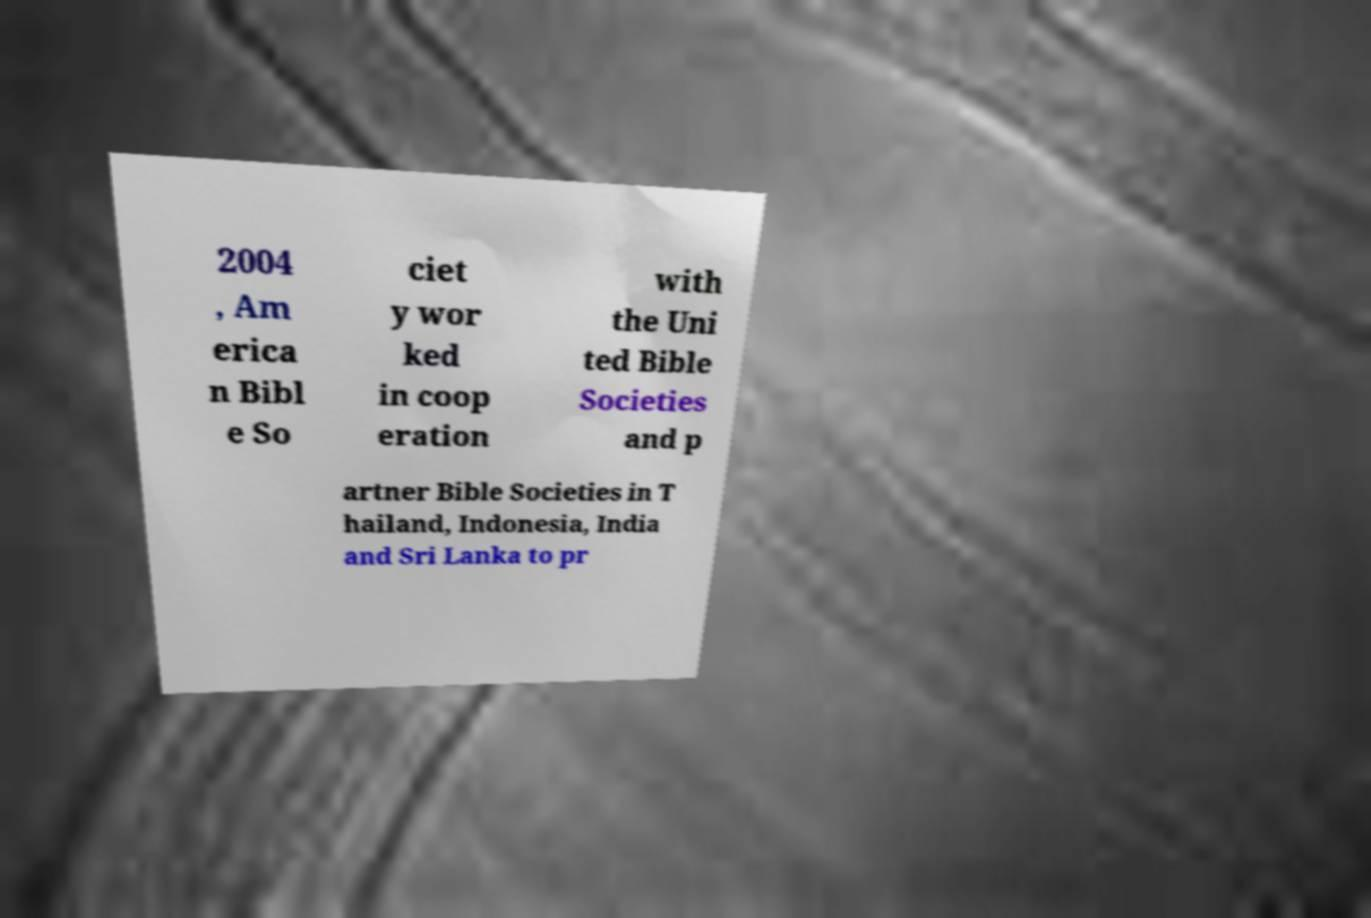For documentation purposes, I need the text within this image transcribed. Could you provide that? 2004 , Am erica n Bibl e So ciet y wor ked in coop eration with the Uni ted Bible Societies and p artner Bible Societies in T hailand, Indonesia, India and Sri Lanka to pr 